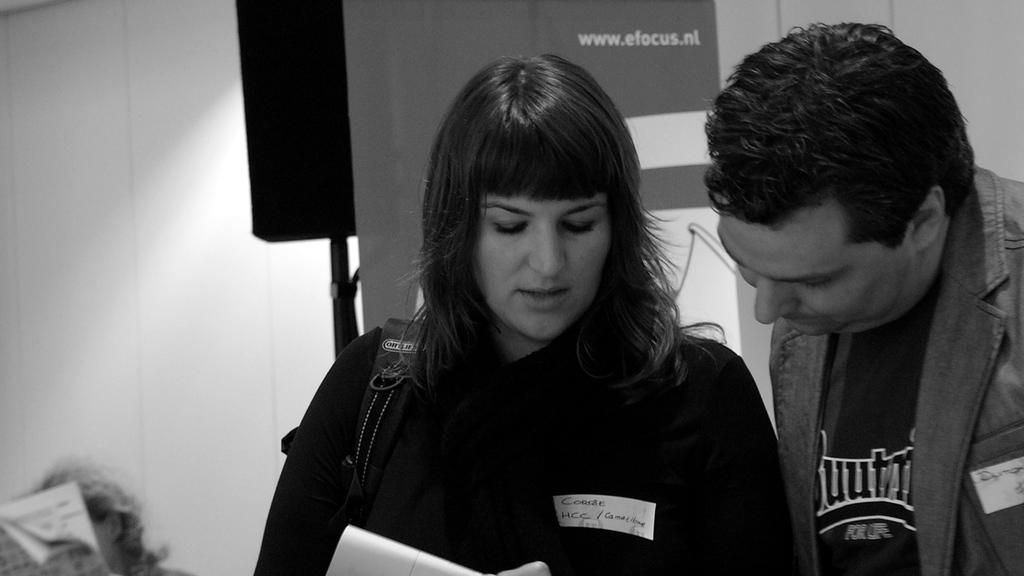From the website shown, i assume this event is in the netherlands isn't it?
Offer a very short reply. Yes. 